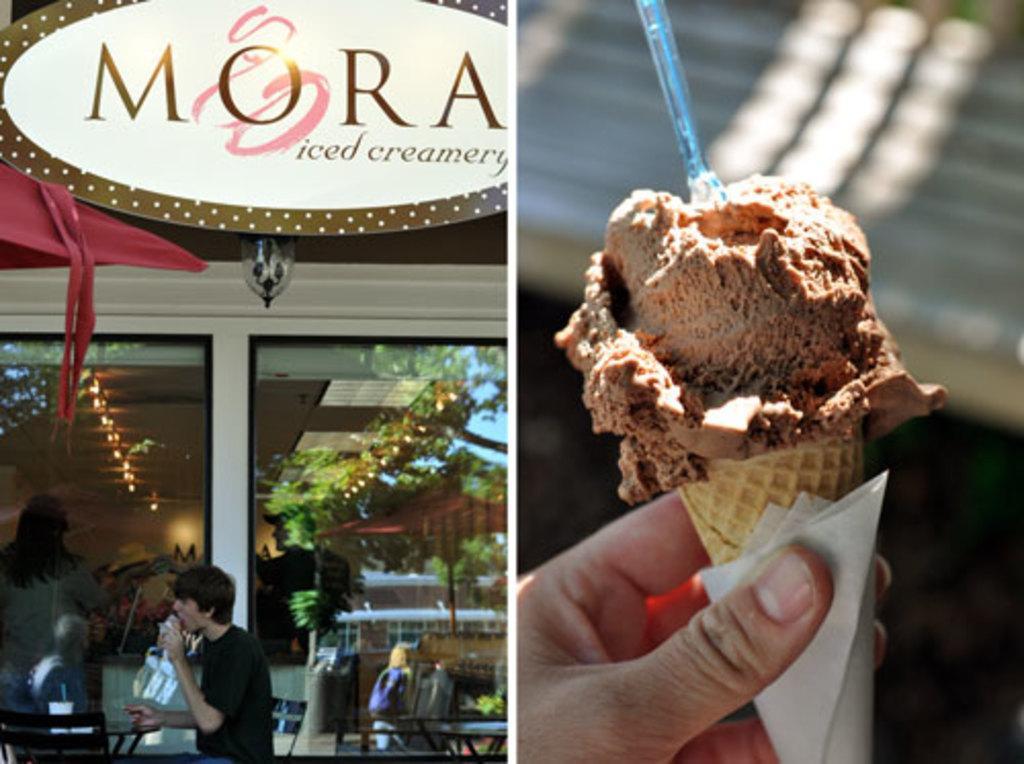Please provide a concise description of this image. This is a collage picture. On the right side of the image I can see an ice cream in a person's hand. On the left side I can see people, tables, chairs, trees, the sky, led board and some other objects. 